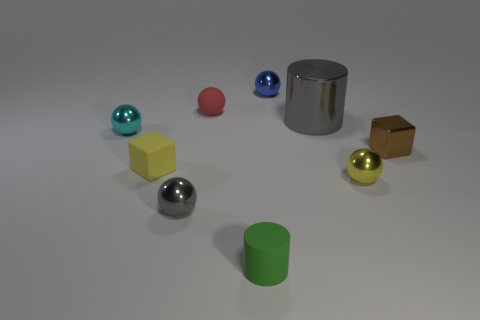There is a small matte thing left of the small gray sphere; is its color the same as the sphere right of the gray shiny cylinder?
Your answer should be very brief. Yes. What is the material of the tiny red thing?
Ensure brevity in your answer.  Rubber. Is there anything else that has the same color as the small matte cube?
Offer a terse response. Yes. Do the tiny gray sphere and the blue sphere have the same material?
Offer a very short reply. Yes. What number of cyan spheres are behind the block that is to the left of the small cube that is right of the small yellow sphere?
Provide a short and direct response. 1. How many gray metal balls are there?
Ensure brevity in your answer.  1. Are there fewer cyan spheres behind the cyan shiny sphere than matte objects that are left of the green matte cylinder?
Offer a very short reply. Yes. Are there fewer small green rubber cylinders that are behind the green object than big brown matte spheres?
Provide a succinct answer. No. There is a brown cube that is behind the tiny cube left of the cylinder that is on the left side of the small blue shiny ball; what is its material?
Give a very brief answer. Metal. How many things are small metal objects in front of the small red rubber thing or small metal spheres behind the brown shiny thing?
Ensure brevity in your answer.  5. 